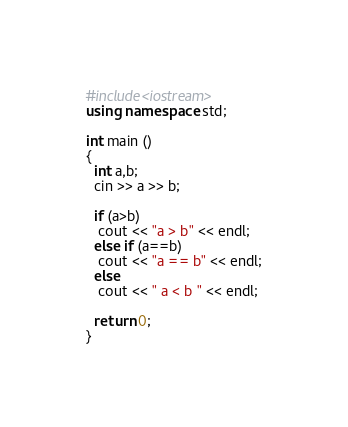Convert code to text. <code><loc_0><loc_0><loc_500><loc_500><_C++_>#include<iostream>
using namespace std;

int main ()
{
  int a,b;
  cin >> a >> b;
 
  if (a>b)
   cout << "a > b" << endl;
  else if (a==b)
   cout << "a == b" << endl;
  else
   cout << " a < b " << endl;

  return 0;
}</code> 